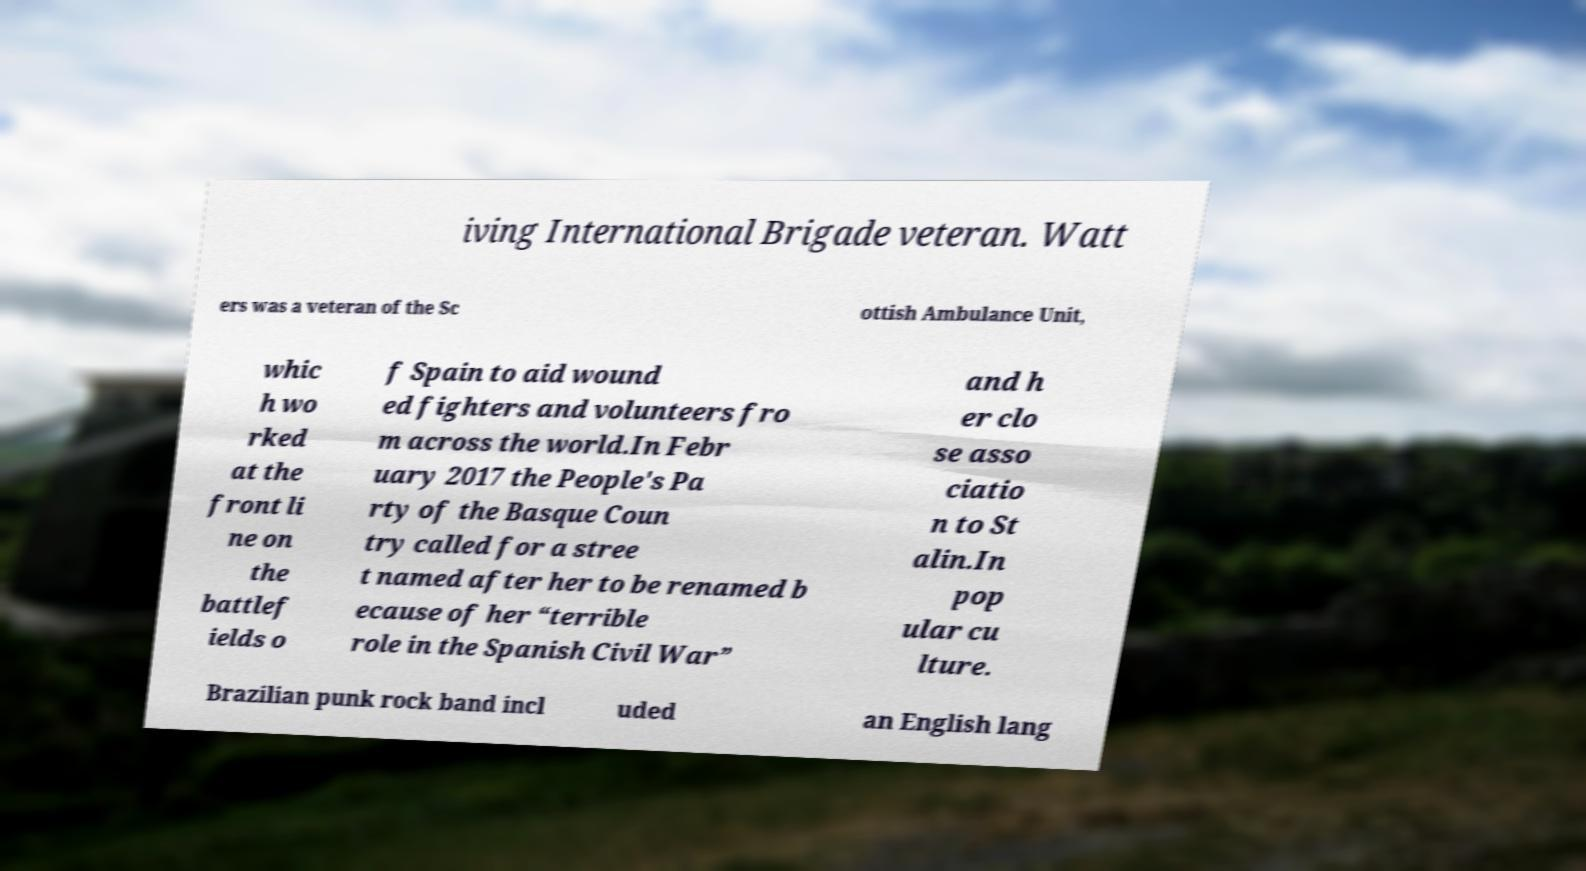Can you read and provide the text displayed in the image?This photo seems to have some interesting text. Can you extract and type it out for me? iving International Brigade veteran. Watt ers was a veteran of the Sc ottish Ambulance Unit, whic h wo rked at the front li ne on the battlef ields o f Spain to aid wound ed fighters and volunteers fro m across the world.In Febr uary 2017 the People's Pa rty of the Basque Coun try called for a stree t named after her to be renamed b ecause of her “terrible role in the Spanish Civil War” and h er clo se asso ciatio n to St alin.In pop ular cu lture. Brazilian punk rock band incl uded an English lang 